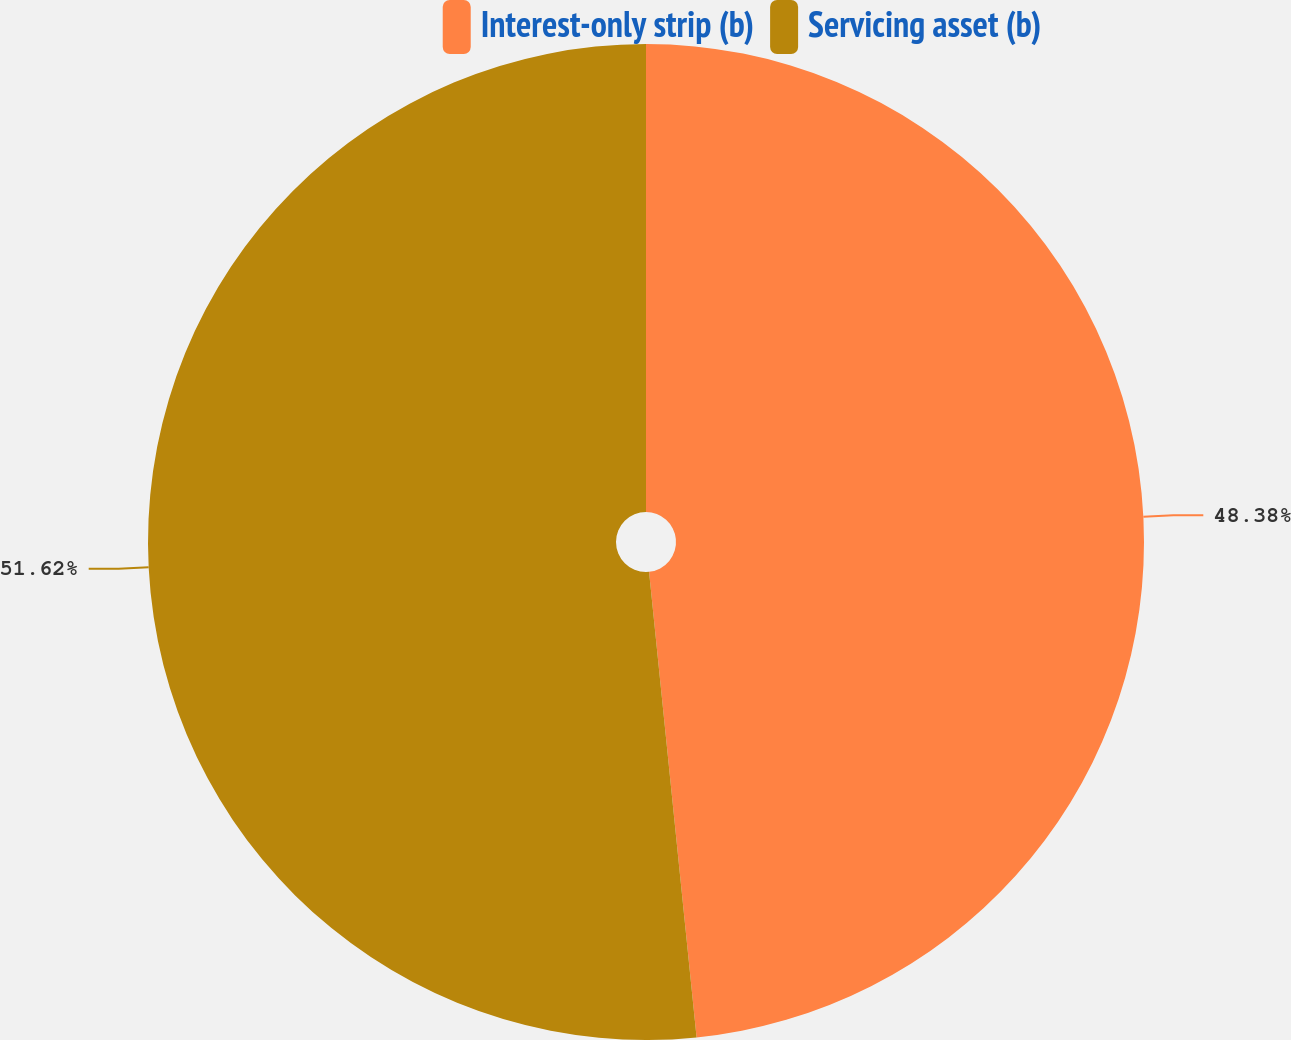Convert chart. <chart><loc_0><loc_0><loc_500><loc_500><pie_chart><fcel>Interest-only strip (b)<fcel>Servicing asset (b)<nl><fcel>48.38%<fcel>51.62%<nl></chart> 